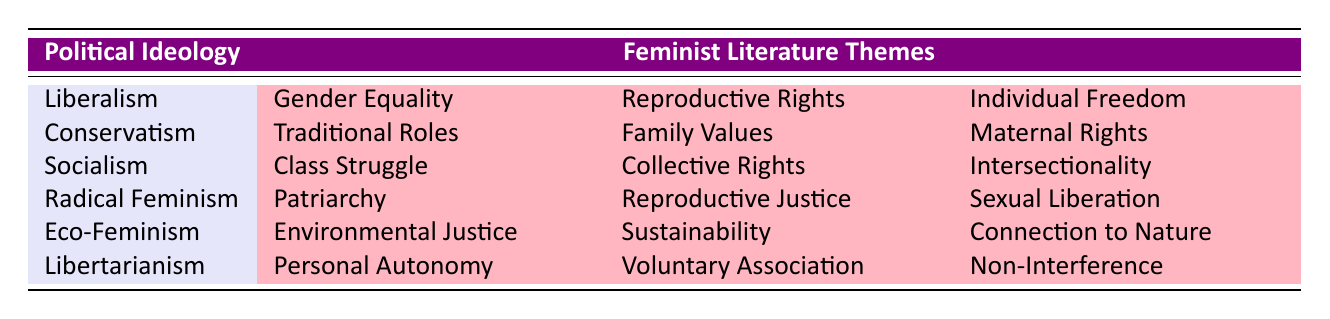What feminist theme is associated with Liberalism? According to the table, Liberalism is associated with three feminist themes: Gender Equality, Reproductive Rights, and Individual Freedom.
Answer: Gender Equality, Reproductive Rights, Individual Freedom What are the feminist themes associated with Conservatism? The table indicates that Conservatism is linked to the feminist themes: Traditional Roles, Family Values, and Maternal Rights.
Answer: Traditional Roles, Family Values, Maternal Rights Does Radical Feminism include the theme of Environmental Justice? By referring to the table, Radical Feminism does not list Environmental Justice as one of its themes; instead, it encompasses Patriarchy, Reproductive Justice, and Sexual Liberation.
Answer: No How many total feminist themes are listed under the different political ideologies? There are 6 political ideologies, each listed with 3 distinct feminist themes, totaling 6 x 3 = 18 feminist themes in the table.
Answer: 18 Which political ideology includes the theme of Intersectionality? Looking at the table, Intersectionality is a feminist theme associated only with Socialism.
Answer: Socialism Do both Eco-Feminism and Libertarianism include the theme of Personal Autonomy? Checking the table shows that only Libertarianism includes Personal Autonomy, while Eco-Feminism lists very different themes: Environmental Justice, Sustainability, and Connection to Nature.
Answer: No Which political ideologies focus on themes related to family and traditional roles? The table indicates that Conservatism explicitly focuses on family and traditional themes, with Traditional Roles and Family Values being central.
Answer: Conservatism List all the political ideologies that include themes advocating autonomy. The table shows that Liberalism and Libertarianism both have themes that advocate for autonomy, with Liberalism focusing on Individual Freedom and Libertarianism on Personal Autonomy.
Answer: Liberalism, Libertarianism What is the relationship between Socialism and the theme of Class Struggle? The table directly correlates Class Struggle as a feminist theme under Socialism, indicating that Socialism emphasizes this aspect in feminist literature.
Answer: Class Struggle is a feminist theme of Socialism 